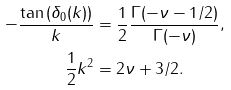Convert formula to latex. <formula><loc_0><loc_0><loc_500><loc_500>- \frac { \tan { ( \delta _ { 0 } ( k ) ) } } { k } & = \frac { 1 } { 2 } \frac { \Gamma ( - \nu - 1 / 2 ) } { \Gamma ( - \nu ) } , \\ \frac { 1 } { 2 } k ^ { 2 } & = 2 \nu + 3 / 2 .</formula> 